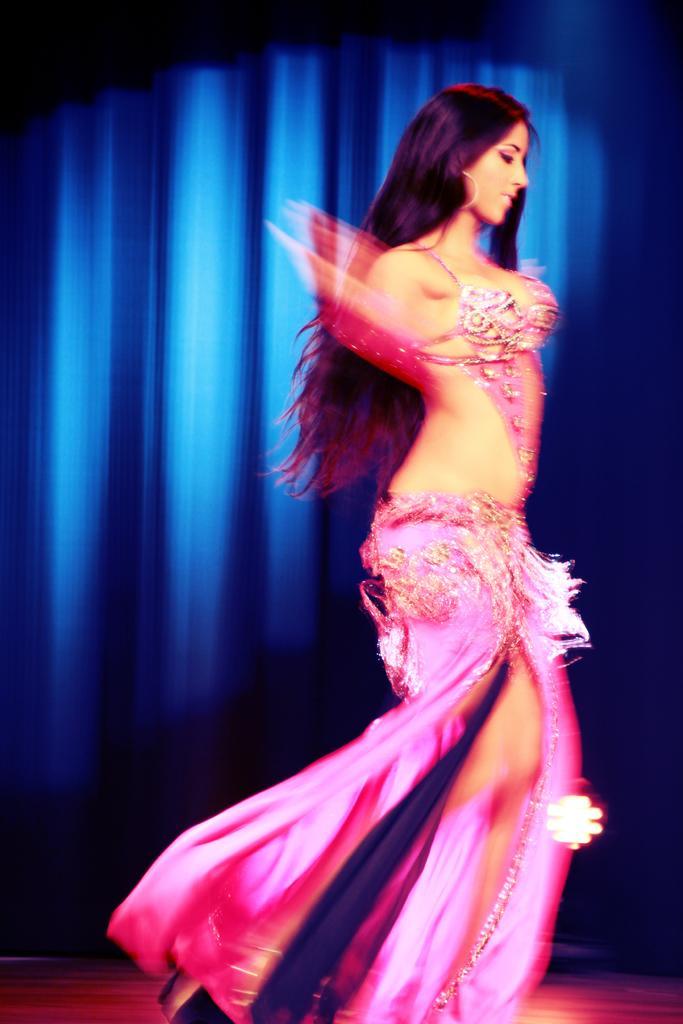Could you give a brief overview of what you see in this image? In this picture we can see a woman is dancing, it looks like a curtain in the background. 